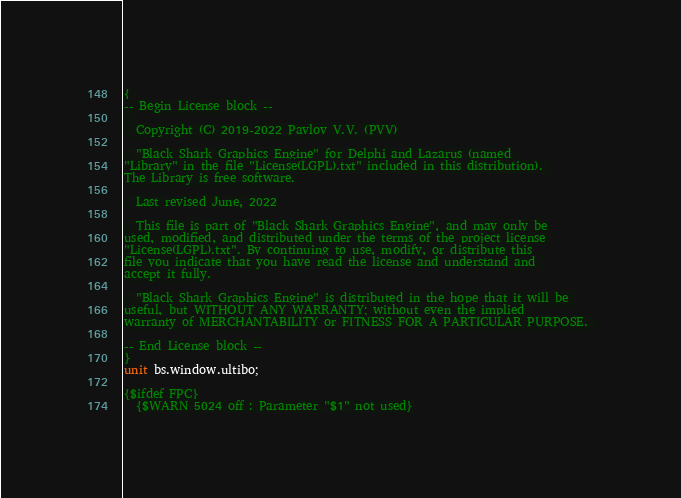<code> <loc_0><loc_0><loc_500><loc_500><_Pascal_>{
-- Begin License block --
  
  Copyright (C) 2019-2022 Pavlov V.V. (PVV)

  "Black Shark Graphics Engine" for Delphi and Lazarus (named 
"Library" in the file "License(LGPL).txt" included in this distribution). 
The Library is free software.

  Last revised June, 2022

  This file is part of "Black Shark Graphics Engine", and may only be
used, modified, and distributed under the terms of the project license 
"License(LGPL).txt". By continuing to use, modify, or distribute this
file you indicate that you have read the license and understand and 
accept it fully.

  "Black Shark Graphics Engine" is distributed in the hope that it will be 
useful, but WITHOUT ANY WARRANTY; without even the implied 
warranty of MERCHANTABILITY or FITNESS FOR A PARTICULAR PURPOSE. 

-- End License block --
}
unit bs.window.ultibo;

{$ifdef FPC}
  {$WARN 5024 off : Parameter "$1" not used}</code> 